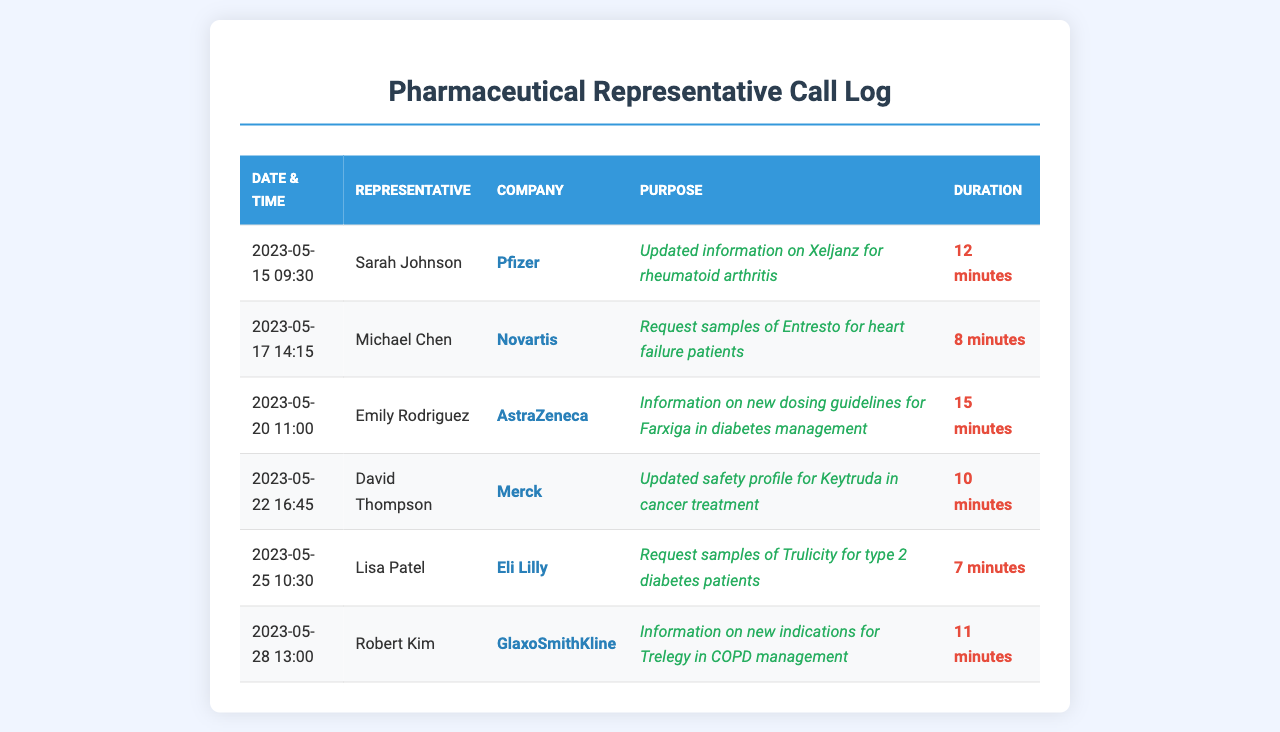what is the date of the call with Pfizer? The date of the call with Pfizer is recorded in the document, which specifies that it took place on 2023-05-15.
Answer: 2023-05-15 who was the representative from Novartis? The representative from Novartis is listed in the document as Michael Chen.
Answer: Michael Chen what was the purpose of the call with AstraZeneca? The purpose of the call with AstraZeneca is detailed as information on new dosing guidelines for Farxiga in diabetes management.
Answer: Information on new dosing guidelines for Farxiga in diabetes management how long was the conversation with Merck? The duration of the conversation with Merck is mentioned in the document as 10 minutes.
Answer: 10 minutes which company requested samples for Trulicity? The document specifies that Eli Lilly was the company that requested samples for Trulicity.
Answer: Eli Lilly how many representatives are listed in the document? The document includes a total of 6 representatives in the call log.
Answer: 6 what company did Robert Kim represent? Robert Kim is noted in the document as representing GlaxoSmithKline.
Answer: GlaxoSmithKline which call took the longest duration? The call that lasted the longest is with Emily Rodriguez from AstraZeneca for 15 minutes.
Answer: 15 minutes what is the purpose of the call with David Thompson from Merck? The purpose of the call with David Thompson is recorded as updated safety profile for Keytruda in cancer treatment.
Answer: Updated safety profile for Keytruda in cancer treatment 